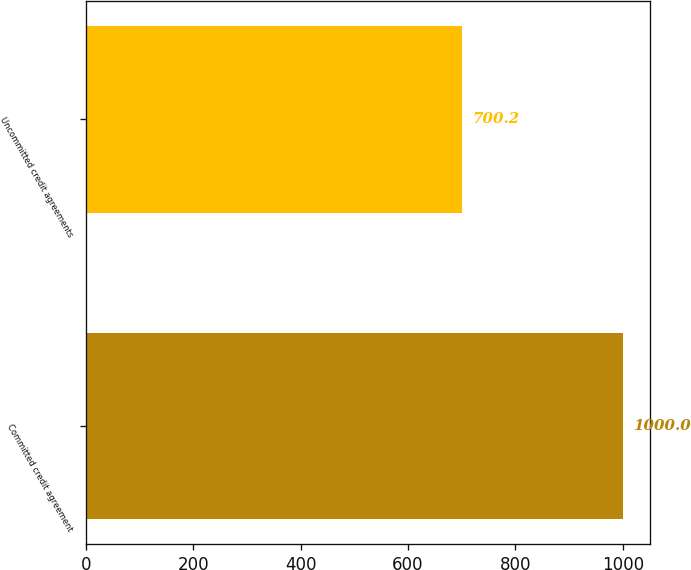<chart> <loc_0><loc_0><loc_500><loc_500><bar_chart><fcel>Committed credit agreement<fcel>Uncommitted credit agreements<nl><fcel>1000<fcel>700.2<nl></chart> 